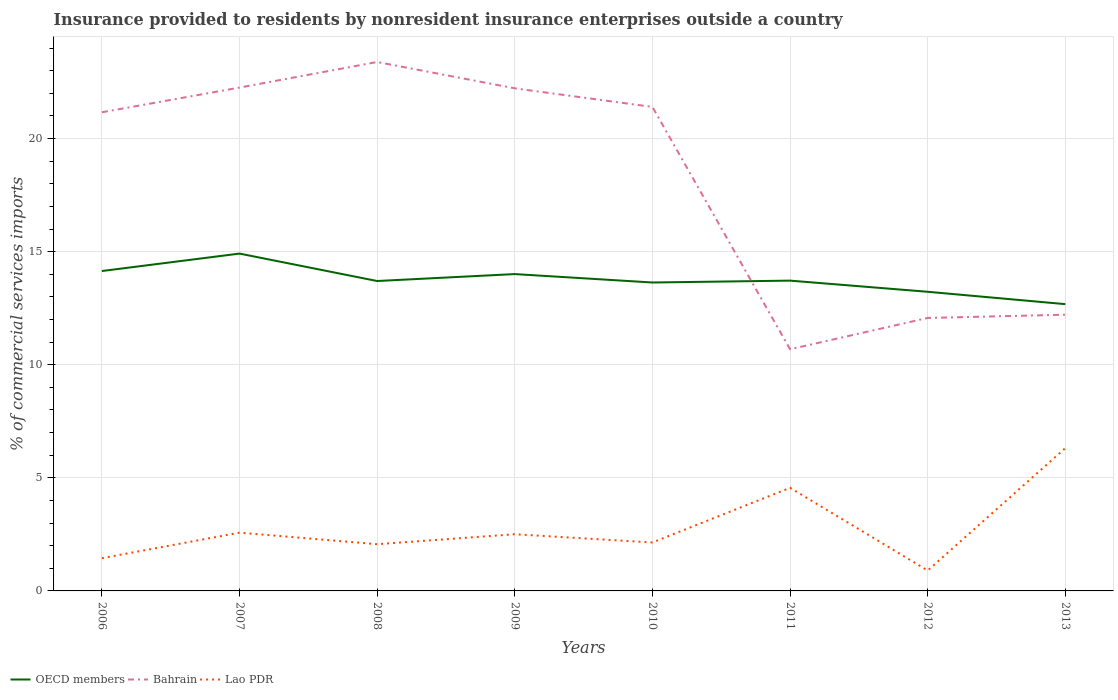How many different coloured lines are there?
Your answer should be very brief. 3. Does the line corresponding to Lao PDR intersect with the line corresponding to OECD members?
Offer a very short reply. No. Is the number of lines equal to the number of legend labels?
Your answer should be very brief. Yes. Across all years, what is the maximum Insurance provided to residents in Lao PDR?
Make the answer very short. 0.9. In which year was the Insurance provided to residents in Bahrain maximum?
Give a very brief answer. 2011. What is the total Insurance provided to residents in OECD members in the graph?
Your response must be concise. 0.44. What is the difference between the highest and the second highest Insurance provided to residents in OECD members?
Offer a terse response. 2.24. What is the difference between the highest and the lowest Insurance provided to residents in Bahrain?
Keep it short and to the point. 5. How many years are there in the graph?
Ensure brevity in your answer.  8. Are the values on the major ticks of Y-axis written in scientific E-notation?
Your answer should be compact. No. Where does the legend appear in the graph?
Ensure brevity in your answer.  Bottom left. How many legend labels are there?
Ensure brevity in your answer.  3. What is the title of the graph?
Give a very brief answer. Insurance provided to residents by nonresident insurance enterprises outside a country. What is the label or title of the X-axis?
Your response must be concise. Years. What is the label or title of the Y-axis?
Ensure brevity in your answer.  % of commercial services imports. What is the % of commercial services imports in OECD members in 2006?
Your answer should be compact. 14.14. What is the % of commercial services imports in Bahrain in 2006?
Provide a short and direct response. 21.16. What is the % of commercial services imports in Lao PDR in 2006?
Give a very brief answer. 1.45. What is the % of commercial services imports of OECD members in 2007?
Your answer should be compact. 14.91. What is the % of commercial services imports of Bahrain in 2007?
Provide a succinct answer. 22.25. What is the % of commercial services imports of Lao PDR in 2007?
Offer a very short reply. 2.58. What is the % of commercial services imports of OECD members in 2008?
Offer a terse response. 13.7. What is the % of commercial services imports in Bahrain in 2008?
Keep it short and to the point. 23.39. What is the % of commercial services imports of Lao PDR in 2008?
Make the answer very short. 2.07. What is the % of commercial services imports of OECD members in 2009?
Offer a very short reply. 14.01. What is the % of commercial services imports in Bahrain in 2009?
Your response must be concise. 22.22. What is the % of commercial services imports in Lao PDR in 2009?
Provide a short and direct response. 2.51. What is the % of commercial services imports of OECD members in 2010?
Give a very brief answer. 13.64. What is the % of commercial services imports in Bahrain in 2010?
Your response must be concise. 21.4. What is the % of commercial services imports of Lao PDR in 2010?
Keep it short and to the point. 2.14. What is the % of commercial services imports of OECD members in 2011?
Give a very brief answer. 13.72. What is the % of commercial services imports in Bahrain in 2011?
Give a very brief answer. 10.68. What is the % of commercial services imports in Lao PDR in 2011?
Provide a succinct answer. 4.56. What is the % of commercial services imports in OECD members in 2012?
Give a very brief answer. 13.23. What is the % of commercial services imports in Bahrain in 2012?
Make the answer very short. 12.07. What is the % of commercial services imports in Lao PDR in 2012?
Make the answer very short. 0.9. What is the % of commercial services imports of OECD members in 2013?
Your answer should be compact. 12.68. What is the % of commercial services imports of Bahrain in 2013?
Ensure brevity in your answer.  12.21. What is the % of commercial services imports of Lao PDR in 2013?
Keep it short and to the point. 6.31. Across all years, what is the maximum % of commercial services imports of OECD members?
Give a very brief answer. 14.91. Across all years, what is the maximum % of commercial services imports of Bahrain?
Give a very brief answer. 23.39. Across all years, what is the maximum % of commercial services imports of Lao PDR?
Your answer should be compact. 6.31. Across all years, what is the minimum % of commercial services imports of OECD members?
Ensure brevity in your answer.  12.68. Across all years, what is the minimum % of commercial services imports of Bahrain?
Keep it short and to the point. 10.68. Across all years, what is the minimum % of commercial services imports in Lao PDR?
Offer a very short reply. 0.9. What is the total % of commercial services imports in OECD members in the graph?
Ensure brevity in your answer.  110.03. What is the total % of commercial services imports of Bahrain in the graph?
Offer a very short reply. 145.39. What is the total % of commercial services imports in Lao PDR in the graph?
Give a very brief answer. 22.51. What is the difference between the % of commercial services imports of OECD members in 2006 and that in 2007?
Provide a short and direct response. -0.77. What is the difference between the % of commercial services imports in Bahrain in 2006 and that in 2007?
Make the answer very short. -1.09. What is the difference between the % of commercial services imports of Lao PDR in 2006 and that in 2007?
Your answer should be very brief. -1.13. What is the difference between the % of commercial services imports of OECD members in 2006 and that in 2008?
Provide a succinct answer. 0.44. What is the difference between the % of commercial services imports in Bahrain in 2006 and that in 2008?
Give a very brief answer. -2.22. What is the difference between the % of commercial services imports of Lao PDR in 2006 and that in 2008?
Make the answer very short. -0.62. What is the difference between the % of commercial services imports of OECD members in 2006 and that in 2009?
Make the answer very short. 0.14. What is the difference between the % of commercial services imports of Bahrain in 2006 and that in 2009?
Provide a short and direct response. -1.06. What is the difference between the % of commercial services imports in Lao PDR in 2006 and that in 2009?
Your answer should be compact. -1.06. What is the difference between the % of commercial services imports of OECD members in 2006 and that in 2010?
Your response must be concise. 0.51. What is the difference between the % of commercial services imports in Bahrain in 2006 and that in 2010?
Your response must be concise. -0.24. What is the difference between the % of commercial services imports of Lao PDR in 2006 and that in 2010?
Your answer should be very brief. -0.69. What is the difference between the % of commercial services imports of OECD members in 2006 and that in 2011?
Provide a short and direct response. 0.42. What is the difference between the % of commercial services imports of Bahrain in 2006 and that in 2011?
Provide a short and direct response. 10.48. What is the difference between the % of commercial services imports of Lao PDR in 2006 and that in 2011?
Give a very brief answer. -3.11. What is the difference between the % of commercial services imports in OECD members in 2006 and that in 2012?
Offer a very short reply. 0.92. What is the difference between the % of commercial services imports of Bahrain in 2006 and that in 2012?
Provide a short and direct response. 9.09. What is the difference between the % of commercial services imports in Lao PDR in 2006 and that in 2012?
Keep it short and to the point. 0.55. What is the difference between the % of commercial services imports in OECD members in 2006 and that in 2013?
Your answer should be very brief. 1.46. What is the difference between the % of commercial services imports in Bahrain in 2006 and that in 2013?
Keep it short and to the point. 8.95. What is the difference between the % of commercial services imports of Lao PDR in 2006 and that in 2013?
Provide a succinct answer. -4.87. What is the difference between the % of commercial services imports of OECD members in 2007 and that in 2008?
Provide a short and direct response. 1.21. What is the difference between the % of commercial services imports of Bahrain in 2007 and that in 2008?
Your answer should be compact. -1.13. What is the difference between the % of commercial services imports in Lao PDR in 2007 and that in 2008?
Give a very brief answer. 0.51. What is the difference between the % of commercial services imports in OECD members in 2007 and that in 2009?
Offer a terse response. 0.91. What is the difference between the % of commercial services imports of Bahrain in 2007 and that in 2009?
Make the answer very short. 0.03. What is the difference between the % of commercial services imports of Lao PDR in 2007 and that in 2009?
Your response must be concise. 0.07. What is the difference between the % of commercial services imports in OECD members in 2007 and that in 2010?
Keep it short and to the point. 1.28. What is the difference between the % of commercial services imports in Bahrain in 2007 and that in 2010?
Provide a succinct answer. 0.86. What is the difference between the % of commercial services imports of Lao PDR in 2007 and that in 2010?
Keep it short and to the point. 0.43. What is the difference between the % of commercial services imports in OECD members in 2007 and that in 2011?
Keep it short and to the point. 1.2. What is the difference between the % of commercial services imports in Bahrain in 2007 and that in 2011?
Your response must be concise. 11.57. What is the difference between the % of commercial services imports of Lao PDR in 2007 and that in 2011?
Give a very brief answer. -1.98. What is the difference between the % of commercial services imports of OECD members in 2007 and that in 2012?
Provide a succinct answer. 1.69. What is the difference between the % of commercial services imports in Bahrain in 2007 and that in 2012?
Your answer should be compact. 10.19. What is the difference between the % of commercial services imports in Lao PDR in 2007 and that in 2012?
Offer a terse response. 1.67. What is the difference between the % of commercial services imports of OECD members in 2007 and that in 2013?
Provide a short and direct response. 2.24. What is the difference between the % of commercial services imports of Bahrain in 2007 and that in 2013?
Make the answer very short. 10.04. What is the difference between the % of commercial services imports in Lao PDR in 2007 and that in 2013?
Your response must be concise. -3.74. What is the difference between the % of commercial services imports of OECD members in 2008 and that in 2009?
Make the answer very short. -0.31. What is the difference between the % of commercial services imports of Bahrain in 2008 and that in 2009?
Provide a short and direct response. 1.16. What is the difference between the % of commercial services imports of Lao PDR in 2008 and that in 2009?
Make the answer very short. -0.44. What is the difference between the % of commercial services imports of OECD members in 2008 and that in 2010?
Make the answer very short. 0.07. What is the difference between the % of commercial services imports in Bahrain in 2008 and that in 2010?
Make the answer very short. 1.99. What is the difference between the % of commercial services imports in Lao PDR in 2008 and that in 2010?
Your answer should be very brief. -0.08. What is the difference between the % of commercial services imports of OECD members in 2008 and that in 2011?
Offer a very short reply. -0.02. What is the difference between the % of commercial services imports of Bahrain in 2008 and that in 2011?
Keep it short and to the point. 12.7. What is the difference between the % of commercial services imports of Lao PDR in 2008 and that in 2011?
Offer a terse response. -2.49. What is the difference between the % of commercial services imports in OECD members in 2008 and that in 2012?
Provide a short and direct response. 0.48. What is the difference between the % of commercial services imports in Bahrain in 2008 and that in 2012?
Ensure brevity in your answer.  11.32. What is the difference between the % of commercial services imports in Lao PDR in 2008 and that in 2012?
Your answer should be very brief. 1.16. What is the difference between the % of commercial services imports in OECD members in 2008 and that in 2013?
Keep it short and to the point. 1.02. What is the difference between the % of commercial services imports in Bahrain in 2008 and that in 2013?
Your answer should be very brief. 11.17. What is the difference between the % of commercial services imports in Lao PDR in 2008 and that in 2013?
Keep it short and to the point. -4.25. What is the difference between the % of commercial services imports of OECD members in 2009 and that in 2010?
Offer a terse response. 0.37. What is the difference between the % of commercial services imports of Bahrain in 2009 and that in 2010?
Provide a succinct answer. 0.82. What is the difference between the % of commercial services imports in Lao PDR in 2009 and that in 2010?
Give a very brief answer. 0.36. What is the difference between the % of commercial services imports of OECD members in 2009 and that in 2011?
Offer a terse response. 0.29. What is the difference between the % of commercial services imports of Bahrain in 2009 and that in 2011?
Your answer should be very brief. 11.54. What is the difference between the % of commercial services imports of Lao PDR in 2009 and that in 2011?
Your answer should be compact. -2.05. What is the difference between the % of commercial services imports in OECD members in 2009 and that in 2012?
Provide a succinct answer. 0.78. What is the difference between the % of commercial services imports in Bahrain in 2009 and that in 2012?
Your answer should be very brief. 10.15. What is the difference between the % of commercial services imports in Lao PDR in 2009 and that in 2012?
Give a very brief answer. 1.6. What is the difference between the % of commercial services imports in OECD members in 2009 and that in 2013?
Ensure brevity in your answer.  1.33. What is the difference between the % of commercial services imports in Bahrain in 2009 and that in 2013?
Your answer should be compact. 10.01. What is the difference between the % of commercial services imports of Lao PDR in 2009 and that in 2013?
Give a very brief answer. -3.81. What is the difference between the % of commercial services imports in OECD members in 2010 and that in 2011?
Your answer should be very brief. -0.08. What is the difference between the % of commercial services imports in Bahrain in 2010 and that in 2011?
Offer a terse response. 10.71. What is the difference between the % of commercial services imports in Lao PDR in 2010 and that in 2011?
Your response must be concise. -2.42. What is the difference between the % of commercial services imports in OECD members in 2010 and that in 2012?
Provide a succinct answer. 0.41. What is the difference between the % of commercial services imports in Bahrain in 2010 and that in 2012?
Offer a very short reply. 9.33. What is the difference between the % of commercial services imports in Lao PDR in 2010 and that in 2012?
Keep it short and to the point. 1.24. What is the difference between the % of commercial services imports in OECD members in 2010 and that in 2013?
Your response must be concise. 0.96. What is the difference between the % of commercial services imports in Bahrain in 2010 and that in 2013?
Make the answer very short. 9.19. What is the difference between the % of commercial services imports in Lao PDR in 2010 and that in 2013?
Keep it short and to the point. -4.17. What is the difference between the % of commercial services imports in OECD members in 2011 and that in 2012?
Offer a terse response. 0.49. What is the difference between the % of commercial services imports in Bahrain in 2011 and that in 2012?
Give a very brief answer. -1.38. What is the difference between the % of commercial services imports of Lao PDR in 2011 and that in 2012?
Make the answer very short. 3.66. What is the difference between the % of commercial services imports in OECD members in 2011 and that in 2013?
Offer a very short reply. 1.04. What is the difference between the % of commercial services imports of Bahrain in 2011 and that in 2013?
Provide a short and direct response. -1.53. What is the difference between the % of commercial services imports in Lao PDR in 2011 and that in 2013?
Give a very brief answer. -1.76. What is the difference between the % of commercial services imports of OECD members in 2012 and that in 2013?
Provide a short and direct response. 0.55. What is the difference between the % of commercial services imports of Bahrain in 2012 and that in 2013?
Offer a very short reply. -0.14. What is the difference between the % of commercial services imports of Lao PDR in 2012 and that in 2013?
Provide a short and direct response. -5.41. What is the difference between the % of commercial services imports of OECD members in 2006 and the % of commercial services imports of Bahrain in 2007?
Make the answer very short. -8.11. What is the difference between the % of commercial services imports in OECD members in 2006 and the % of commercial services imports in Lao PDR in 2007?
Your response must be concise. 11.57. What is the difference between the % of commercial services imports of Bahrain in 2006 and the % of commercial services imports of Lao PDR in 2007?
Your answer should be very brief. 18.59. What is the difference between the % of commercial services imports of OECD members in 2006 and the % of commercial services imports of Bahrain in 2008?
Your response must be concise. -9.24. What is the difference between the % of commercial services imports of OECD members in 2006 and the % of commercial services imports of Lao PDR in 2008?
Your answer should be compact. 12.08. What is the difference between the % of commercial services imports of Bahrain in 2006 and the % of commercial services imports of Lao PDR in 2008?
Your answer should be compact. 19.1. What is the difference between the % of commercial services imports of OECD members in 2006 and the % of commercial services imports of Bahrain in 2009?
Your answer should be compact. -8.08. What is the difference between the % of commercial services imports of OECD members in 2006 and the % of commercial services imports of Lao PDR in 2009?
Offer a terse response. 11.64. What is the difference between the % of commercial services imports of Bahrain in 2006 and the % of commercial services imports of Lao PDR in 2009?
Your answer should be compact. 18.66. What is the difference between the % of commercial services imports in OECD members in 2006 and the % of commercial services imports in Bahrain in 2010?
Your answer should be compact. -7.25. What is the difference between the % of commercial services imports of OECD members in 2006 and the % of commercial services imports of Lao PDR in 2010?
Offer a terse response. 12. What is the difference between the % of commercial services imports of Bahrain in 2006 and the % of commercial services imports of Lao PDR in 2010?
Keep it short and to the point. 19.02. What is the difference between the % of commercial services imports in OECD members in 2006 and the % of commercial services imports in Bahrain in 2011?
Provide a succinct answer. 3.46. What is the difference between the % of commercial services imports in OECD members in 2006 and the % of commercial services imports in Lao PDR in 2011?
Your answer should be very brief. 9.59. What is the difference between the % of commercial services imports of Bahrain in 2006 and the % of commercial services imports of Lao PDR in 2011?
Give a very brief answer. 16.6. What is the difference between the % of commercial services imports of OECD members in 2006 and the % of commercial services imports of Bahrain in 2012?
Your response must be concise. 2.07. What is the difference between the % of commercial services imports in OECD members in 2006 and the % of commercial services imports in Lao PDR in 2012?
Offer a very short reply. 13.24. What is the difference between the % of commercial services imports of Bahrain in 2006 and the % of commercial services imports of Lao PDR in 2012?
Provide a succinct answer. 20.26. What is the difference between the % of commercial services imports of OECD members in 2006 and the % of commercial services imports of Bahrain in 2013?
Your answer should be very brief. 1.93. What is the difference between the % of commercial services imports of OECD members in 2006 and the % of commercial services imports of Lao PDR in 2013?
Your answer should be compact. 7.83. What is the difference between the % of commercial services imports in Bahrain in 2006 and the % of commercial services imports in Lao PDR in 2013?
Keep it short and to the point. 14.85. What is the difference between the % of commercial services imports of OECD members in 2007 and the % of commercial services imports of Bahrain in 2008?
Your response must be concise. -8.47. What is the difference between the % of commercial services imports of OECD members in 2007 and the % of commercial services imports of Lao PDR in 2008?
Provide a succinct answer. 12.85. What is the difference between the % of commercial services imports of Bahrain in 2007 and the % of commercial services imports of Lao PDR in 2008?
Provide a succinct answer. 20.19. What is the difference between the % of commercial services imports in OECD members in 2007 and the % of commercial services imports in Bahrain in 2009?
Ensure brevity in your answer.  -7.31. What is the difference between the % of commercial services imports of OECD members in 2007 and the % of commercial services imports of Lao PDR in 2009?
Your answer should be very brief. 12.41. What is the difference between the % of commercial services imports of Bahrain in 2007 and the % of commercial services imports of Lao PDR in 2009?
Offer a terse response. 19.75. What is the difference between the % of commercial services imports in OECD members in 2007 and the % of commercial services imports in Bahrain in 2010?
Ensure brevity in your answer.  -6.48. What is the difference between the % of commercial services imports of OECD members in 2007 and the % of commercial services imports of Lao PDR in 2010?
Your answer should be compact. 12.77. What is the difference between the % of commercial services imports of Bahrain in 2007 and the % of commercial services imports of Lao PDR in 2010?
Give a very brief answer. 20.11. What is the difference between the % of commercial services imports in OECD members in 2007 and the % of commercial services imports in Bahrain in 2011?
Offer a very short reply. 4.23. What is the difference between the % of commercial services imports in OECD members in 2007 and the % of commercial services imports in Lao PDR in 2011?
Your answer should be compact. 10.36. What is the difference between the % of commercial services imports in Bahrain in 2007 and the % of commercial services imports in Lao PDR in 2011?
Your answer should be very brief. 17.7. What is the difference between the % of commercial services imports of OECD members in 2007 and the % of commercial services imports of Bahrain in 2012?
Ensure brevity in your answer.  2.85. What is the difference between the % of commercial services imports of OECD members in 2007 and the % of commercial services imports of Lao PDR in 2012?
Provide a succinct answer. 14.01. What is the difference between the % of commercial services imports in Bahrain in 2007 and the % of commercial services imports in Lao PDR in 2012?
Your answer should be compact. 21.35. What is the difference between the % of commercial services imports in OECD members in 2007 and the % of commercial services imports in Bahrain in 2013?
Provide a succinct answer. 2.7. What is the difference between the % of commercial services imports in Bahrain in 2007 and the % of commercial services imports in Lao PDR in 2013?
Offer a very short reply. 15.94. What is the difference between the % of commercial services imports of OECD members in 2008 and the % of commercial services imports of Bahrain in 2009?
Provide a succinct answer. -8.52. What is the difference between the % of commercial services imports of OECD members in 2008 and the % of commercial services imports of Lao PDR in 2009?
Keep it short and to the point. 11.2. What is the difference between the % of commercial services imports of Bahrain in 2008 and the % of commercial services imports of Lao PDR in 2009?
Give a very brief answer. 20.88. What is the difference between the % of commercial services imports in OECD members in 2008 and the % of commercial services imports in Bahrain in 2010?
Give a very brief answer. -7.7. What is the difference between the % of commercial services imports of OECD members in 2008 and the % of commercial services imports of Lao PDR in 2010?
Provide a short and direct response. 11.56. What is the difference between the % of commercial services imports of Bahrain in 2008 and the % of commercial services imports of Lao PDR in 2010?
Give a very brief answer. 21.24. What is the difference between the % of commercial services imports in OECD members in 2008 and the % of commercial services imports in Bahrain in 2011?
Your response must be concise. 3.02. What is the difference between the % of commercial services imports of OECD members in 2008 and the % of commercial services imports of Lao PDR in 2011?
Make the answer very short. 9.14. What is the difference between the % of commercial services imports of Bahrain in 2008 and the % of commercial services imports of Lao PDR in 2011?
Offer a terse response. 18.83. What is the difference between the % of commercial services imports of OECD members in 2008 and the % of commercial services imports of Bahrain in 2012?
Your response must be concise. 1.63. What is the difference between the % of commercial services imports in OECD members in 2008 and the % of commercial services imports in Lao PDR in 2012?
Make the answer very short. 12.8. What is the difference between the % of commercial services imports of Bahrain in 2008 and the % of commercial services imports of Lao PDR in 2012?
Keep it short and to the point. 22.48. What is the difference between the % of commercial services imports in OECD members in 2008 and the % of commercial services imports in Bahrain in 2013?
Offer a very short reply. 1.49. What is the difference between the % of commercial services imports of OECD members in 2008 and the % of commercial services imports of Lao PDR in 2013?
Provide a short and direct response. 7.39. What is the difference between the % of commercial services imports in Bahrain in 2008 and the % of commercial services imports in Lao PDR in 2013?
Your answer should be compact. 17.07. What is the difference between the % of commercial services imports in OECD members in 2009 and the % of commercial services imports in Bahrain in 2010?
Ensure brevity in your answer.  -7.39. What is the difference between the % of commercial services imports of OECD members in 2009 and the % of commercial services imports of Lao PDR in 2010?
Your response must be concise. 11.87. What is the difference between the % of commercial services imports in Bahrain in 2009 and the % of commercial services imports in Lao PDR in 2010?
Offer a terse response. 20.08. What is the difference between the % of commercial services imports in OECD members in 2009 and the % of commercial services imports in Bahrain in 2011?
Your answer should be compact. 3.32. What is the difference between the % of commercial services imports in OECD members in 2009 and the % of commercial services imports in Lao PDR in 2011?
Your response must be concise. 9.45. What is the difference between the % of commercial services imports of Bahrain in 2009 and the % of commercial services imports of Lao PDR in 2011?
Your answer should be very brief. 17.66. What is the difference between the % of commercial services imports of OECD members in 2009 and the % of commercial services imports of Bahrain in 2012?
Your response must be concise. 1.94. What is the difference between the % of commercial services imports in OECD members in 2009 and the % of commercial services imports in Lao PDR in 2012?
Provide a succinct answer. 13.11. What is the difference between the % of commercial services imports in Bahrain in 2009 and the % of commercial services imports in Lao PDR in 2012?
Your response must be concise. 21.32. What is the difference between the % of commercial services imports in OECD members in 2009 and the % of commercial services imports in Bahrain in 2013?
Your response must be concise. 1.8. What is the difference between the % of commercial services imports in OECD members in 2009 and the % of commercial services imports in Lao PDR in 2013?
Provide a short and direct response. 7.69. What is the difference between the % of commercial services imports in Bahrain in 2009 and the % of commercial services imports in Lao PDR in 2013?
Your response must be concise. 15.91. What is the difference between the % of commercial services imports of OECD members in 2010 and the % of commercial services imports of Bahrain in 2011?
Offer a very short reply. 2.95. What is the difference between the % of commercial services imports in OECD members in 2010 and the % of commercial services imports in Lao PDR in 2011?
Keep it short and to the point. 9.08. What is the difference between the % of commercial services imports in Bahrain in 2010 and the % of commercial services imports in Lao PDR in 2011?
Give a very brief answer. 16.84. What is the difference between the % of commercial services imports of OECD members in 2010 and the % of commercial services imports of Bahrain in 2012?
Offer a terse response. 1.57. What is the difference between the % of commercial services imports of OECD members in 2010 and the % of commercial services imports of Lao PDR in 2012?
Keep it short and to the point. 12.73. What is the difference between the % of commercial services imports of Bahrain in 2010 and the % of commercial services imports of Lao PDR in 2012?
Make the answer very short. 20.5. What is the difference between the % of commercial services imports in OECD members in 2010 and the % of commercial services imports in Bahrain in 2013?
Your answer should be compact. 1.42. What is the difference between the % of commercial services imports in OECD members in 2010 and the % of commercial services imports in Lao PDR in 2013?
Provide a short and direct response. 7.32. What is the difference between the % of commercial services imports in Bahrain in 2010 and the % of commercial services imports in Lao PDR in 2013?
Keep it short and to the point. 15.08. What is the difference between the % of commercial services imports in OECD members in 2011 and the % of commercial services imports in Bahrain in 2012?
Make the answer very short. 1.65. What is the difference between the % of commercial services imports in OECD members in 2011 and the % of commercial services imports in Lao PDR in 2012?
Your answer should be compact. 12.82. What is the difference between the % of commercial services imports in Bahrain in 2011 and the % of commercial services imports in Lao PDR in 2012?
Keep it short and to the point. 9.78. What is the difference between the % of commercial services imports of OECD members in 2011 and the % of commercial services imports of Bahrain in 2013?
Make the answer very short. 1.51. What is the difference between the % of commercial services imports of OECD members in 2011 and the % of commercial services imports of Lao PDR in 2013?
Give a very brief answer. 7.4. What is the difference between the % of commercial services imports in Bahrain in 2011 and the % of commercial services imports in Lao PDR in 2013?
Provide a short and direct response. 4.37. What is the difference between the % of commercial services imports in OECD members in 2012 and the % of commercial services imports in Bahrain in 2013?
Make the answer very short. 1.01. What is the difference between the % of commercial services imports of OECD members in 2012 and the % of commercial services imports of Lao PDR in 2013?
Make the answer very short. 6.91. What is the difference between the % of commercial services imports in Bahrain in 2012 and the % of commercial services imports in Lao PDR in 2013?
Offer a terse response. 5.75. What is the average % of commercial services imports of OECD members per year?
Your response must be concise. 13.75. What is the average % of commercial services imports in Bahrain per year?
Make the answer very short. 18.17. What is the average % of commercial services imports of Lao PDR per year?
Your response must be concise. 2.81. In the year 2006, what is the difference between the % of commercial services imports of OECD members and % of commercial services imports of Bahrain?
Keep it short and to the point. -7.02. In the year 2006, what is the difference between the % of commercial services imports of OECD members and % of commercial services imports of Lao PDR?
Your answer should be compact. 12.7. In the year 2006, what is the difference between the % of commercial services imports of Bahrain and % of commercial services imports of Lao PDR?
Your response must be concise. 19.71. In the year 2007, what is the difference between the % of commercial services imports in OECD members and % of commercial services imports in Bahrain?
Give a very brief answer. -7.34. In the year 2007, what is the difference between the % of commercial services imports in OECD members and % of commercial services imports in Lao PDR?
Your answer should be compact. 12.34. In the year 2007, what is the difference between the % of commercial services imports in Bahrain and % of commercial services imports in Lao PDR?
Your answer should be very brief. 19.68. In the year 2008, what is the difference between the % of commercial services imports in OECD members and % of commercial services imports in Bahrain?
Offer a terse response. -9.68. In the year 2008, what is the difference between the % of commercial services imports of OECD members and % of commercial services imports of Lao PDR?
Offer a very short reply. 11.64. In the year 2008, what is the difference between the % of commercial services imports in Bahrain and % of commercial services imports in Lao PDR?
Give a very brief answer. 21.32. In the year 2009, what is the difference between the % of commercial services imports in OECD members and % of commercial services imports in Bahrain?
Provide a succinct answer. -8.21. In the year 2009, what is the difference between the % of commercial services imports in OECD members and % of commercial services imports in Lao PDR?
Ensure brevity in your answer.  11.5. In the year 2009, what is the difference between the % of commercial services imports in Bahrain and % of commercial services imports in Lao PDR?
Provide a short and direct response. 19.72. In the year 2010, what is the difference between the % of commercial services imports of OECD members and % of commercial services imports of Bahrain?
Provide a short and direct response. -7.76. In the year 2010, what is the difference between the % of commercial services imports of OECD members and % of commercial services imports of Lao PDR?
Keep it short and to the point. 11.49. In the year 2010, what is the difference between the % of commercial services imports of Bahrain and % of commercial services imports of Lao PDR?
Ensure brevity in your answer.  19.26. In the year 2011, what is the difference between the % of commercial services imports of OECD members and % of commercial services imports of Bahrain?
Provide a short and direct response. 3.03. In the year 2011, what is the difference between the % of commercial services imports of OECD members and % of commercial services imports of Lao PDR?
Make the answer very short. 9.16. In the year 2011, what is the difference between the % of commercial services imports in Bahrain and % of commercial services imports in Lao PDR?
Offer a very short reply. 6.13. In the year 2012, what is the difference between the % of commercial services imports in OECD members and % of commercial services imports in Bahrain?
Provide a short and direct response. 1.16. In the year 2012, what is the difference between the % of commercial services imports of OECD members and % of commercial services imports of Lao PDR?
Keep it short and to the point. 12.32. In the year 2012, what is the difference between the % of commercial services imports of Bahrain and % of commercial services imports of Lao PDR?
Your answer should be compact. 11.17. In the year 2013, what is the difference between the % of commercial services imports of OECD members and % of commercial services imports of Bahrain?
Your response must be concise. 0.47. In the year 2013, what is the difference between the % of commercial services imports in OECD members and % of commercial services imports in Lao PDR?
Offer a very short reply. 6.36. In the year 2013, what is the difference between the % of commercial services imports in Bahrain and % of commercial services imports in Lao PDR?
Make the answer very short. 5.9. What is the ratio of the % of commercial services imports in OECD members in 2006 to that in 2007?
Ensure brevity in your answer.  0.95. What is the ratio of the % of commercial services imports in Bahrain in 2006 to that in 2007?
Give a very brief answer. 0.95. What is the ratio of the % of commercial services imports in Lao PDR in 2006 to that in 2007?
Offer a terse response. 0.56. What is the ratio of the % of commercial services imports of OECD members in 2006 to that in 2008?
Offer a very short reply. 1.03. What is the ratio of the % of commercial services imports of Bahrain in 2006 to that in 2008?
Offer a terse response. 0.91. What is the ratio of the % of commercial services imports of Lao PDR in 2006 to that in 2008?
Give a very brief answer. 0.7. What is the ratio of the % of commercial services imports in OECD members in 2006 to that in 2009?
Make the answer very short. 1.01. What is the ratio of the % of commercial services imports in Bahrain in 2006 to that in 2009?
Your answer should be very brief. 0.95. What is the ratio of the % of commercial services imports of Lao PDR in 2006 to that in 2009?
Provide a succinct answer. 0.58. What is the ratio of the % of commercial services imports of OECD members in 2006 to that in 2010?
Your answer should be very brief. 1.04. What is the ratio of the % of commercial services imports in Bahrain in 2006 to that in 2010?
Your answer should be very brief. 0.99. What is the ratio of the % of commercial services imports of Lao PDR in 2006 to that in 2010?
Provide a short and direct response. 0.68. What is the ratio of the % of commercial services imports of OECD members in 2006 to that in 2011?
Offer a terse response. 1.03. What is the ratio of the % of commercial services imports of Bahrain in 2006 to that in 2011?
Ensure brevity in your answer.  1.98. What is the ratio of the % of commercial services imports in Lao PDR in 2006 to that in 2011?
Offer a very short reply. 0.32. What is the ratio of the % of commercial services imports in OECD members in 2006 to that in 2012?
Provide a succinct answer. 1.07. What is the ratio of the % of commercial services imports in Bahrain in 2006 to that in 2012?
Keep it short and to the point. 1.75. What is the ratio of the % of commercial services imports of Lao PDR in 2006 to that in 2012?
Your response must be concise. 1.61. What is the ratio of the % of commercial services imports in OECD members in 2006 to that in 2013?
Keep it short and to the point. 1.12. What is the ratio of the % of commercial services imports in Bahrain in 2006 to that in 2013?
Offer a terse response. 1.73. What is the ratio of the % of commercial services imports in Lao PDR in 2006 to that in 2013?
Provide a succinct answer. 0.23. What is the ratio of the % of commercial services imports in OECD members in 2007 to that in 2008?
Make the answer very short. 1.09. What is the ratio of the % of commercial services imports in Bahrain in 2007 to that in 2008?
Make the answer very short. 0.95. What is the ratio of the % of commercial services imports in Lao PDR in 2007 to that in 2008?
Ensure brevity in your answer.  1.25. What is the ratio of the % of commercial services imports in OECD members in 2007 to that in 2009?
Offer a very short reply. 1.06. What is the ratio of the % of commercial services imports of Lao PDR in 2007 to that in 2009?
Keep it short and to the point. 1.03. What is the ratio of the % of commercial services imports in OECD members in 2007 to that in 2010?
Give a very brief answer. 1.09. What is the ratio of the % of commercial services imports of Lao PDR in 2007 to that in 2010?
Ensure brevity in your answer.  1.2. What is the ratio of the % of commercial services imports in OECD members in 2007 to that in 2011?
Provide a succinct answer. 1.09. What is the ratio of the % of commercial services imports of Bahrain in 2007 to that in 2011?
Ensure brevity in your answer.  2.08. What is the ratio of the % of commercial services imports in Lao PDR in 2007 to that in 2011?
Your answer should be compact. 0.57. What is the ratio of the % of commercial services imports of OECD members in 2007 to that in 2012?
Provide a succinct answer. 1.13. What is the ratio of the % of commercial services imports in Bahrain in 2007 to that in 2012?
Give a very brief answer. 1.84. What is the ratio of the % of commercial services imports of Lao PDR in 2007 to that in 2012?
Your response must be concise. 2.86. What is the ratio of the % of commercial services imports in OECD members in 2007 to that in 2013?
Make the answer very short. 1.18. What is the ratio of the % of commercial services imports in Bahrain in 2007 to that in 2013?
Give a very brief answer. 1.82. What is the ratio of the % of commercial services imports in Lao PDR in 2007 to that in 2013?
Provide a succinct answer. 0.41. What is the ratio of the % of commercial services imports in OECD members in 2008 to that in 2009?
Offer a terse response. 0.98. What is the ratio of the % of commercial services imports in Bahrain in 2008 to that in 2009?
Offer a very short reply. 1.05. What is the ratio of the % of commercial services imports of Lao PDR in 2008 to that in 2009?
Keep it short and to the point. 0.82. What is the ratio of the % of commercial services imports of Bahrain in 2008 to that in 2010?
Provide a short and direct response. 1.09. What is the ratio of the % of commercial services imports of Lao PDR in 2008 to that in 2010?
Your answer should be compact. 0.96. What is the ratio of the % of commercial services imports in OECD members in 2008 to that in 2011?
Your answer should be compact. 1. What is the ratio of the % of commercial services imports of Bahrain in 2008 to that in 2011?
Offer a very short reply. 2.19. What is the ratio of the % of commercial services imports in Lao PDR in 2008 to that in 2011?
Ensure brevity in your answer.  0.45. What is the ratio of the % of commercial services imports of OECD members in 2008 to that in 2012?
Provide a succinct answer. 1.04. What is the ratio of the % of commercial services imports in Bahrain in 2008 to that in 2012?
Your answer should be very brief. 1.94. What is the ratio of the % of commercial services imports of Lao PDR in 2008 to that in 2012?
Give a very brief answer. 2.29. What is the ratio of the % of commercial services imports of OECD members in 2008 to that in 2013?
Ensure brevity in your answer.  1.08. What is the ratio of the % of commercial services imports in Bahrain in 2008 to that in 2013?
Ensure brevity in your answer.  1.91. What is the ratio of the % of commercial services imports in Lao PDR in 2008 to that in 2013?
Your answer should be very brief. 0.33. What is the ratio of the % of commercial services imports of OECD members in 2009 to that in 2010?
Your response must be concise. 1.03. What is the ratio of the % of commercial services imports of Bahrain in 2009 to that in 2010?
Keep it short and to the point. 1.04. What is the ratio of the % of commercial services imports in Lao PDR in 2009 to that in 2010?
Give a very brief answer. 1.17. What is the ratio of the % of commercial services imports in OECD members in 2009 to that in 2011?
Provide a short and direct response. 1.02. What is the ratio of the % of commercial services imports in Bahrain in 2009 to that in 2011?
Give a very brief answer. 2.08. What is the ratio of the % of commercial services imports in Lao PDR in 2009 to that in 2011?
Provide a short and direct response. 0.55. What is the ratio of the % of commercial services imports in OECD members in 2009 to that in 2012?
Make the answer very short. 1.06. What is the ratio of the % of commercial services imports in Bahrain in 2009 to that in 2012?
Provide a succinct answer. 1.84. What is the ratio of the % of commercial services imports in Lao PDR in 2009 to that in 2012?
Provide a short and direct response. 2.78. What is the ratio of the % of commercial services imports of OECD members in 2009 to that in 2013?
Offer a very short reply. 1.1. What is the ratio of the % of commercial services imports of Bahrain in 2009 to that in 2013?
Your response must be concise. 1.82. What is the ratio of the % of commercial services imports of Lao PDR in 2009 to that in 2013?
Provide a short and direct response. 0.4. What is the ratio of the % of commercial services imports in OECD members in 2010 to that in 2011?
Keep it short and to the point. 0.99. What is the ratio of the % of commercial services imports of Bahrain in 2010 to that in 2011?
Offer a terse response. 2. What is the ratio of the % of commercial services imports in Lao PDR in 2010 to that in 2011?
Your answer should be very brief. 0.47. What is the ratio of the % of commercial services imports in OECD members in 2010 to that in 2012?
Make the answer very short. 1.03. What is the ratio of the % of commercial services imports in Bahrain in 2010 to that in 2012?
Your response must be concise. 1.77. What is the ratio of the % of commercial services imports in Lao PDR in 2010 to that in 2012?
Make the answer very short. 2.38. What is the ratio of the % of commercial services imports in OECD members in 2010 to that in 2013?
Make the answer very short. 1.08. What is the ratio of the % of commercial services imports in Bahrain in 2010 to that in 2013?
Offer a very short reply. 1.75. What is the ratio of the % of commercial services imports in Lao PDR in 2010 to that in 2013?
Your answer should be compact. 0.34. What is the ratio of the % of commercial services imports of OECD members in 2011 to that in 2012?
Offer a terse response. 1.04. What is the ratio of the % of commercial services imports of Bahrain in 2011 to that in 2012?
Keep it short and to the point. 0.89. What is the ratio of the % of commercial services imports of Lao PDR in 2011 to that in 2012?
Your response must be concise. 5.06. What is the ratio of the % of commercial services imports of OECD members in 2011 to that in 2013?
Make the answer very short. 1.08. What is the ratio of the % of commercial services imports of Bahrain in 2011 to that in 2013?
Your answer should be compact. 0.87. What is the ratio of the % of commercial services imports of Lao PDR in 2011 to that in 2013?
Your answer should be compact. 0.72. What is the ratio of the % of commercial services imports of OECD members in 2012 to that in 2013?
Make the answer very short. 1.04. What is the ratio of the % of commercial services imports of Bahrain in 2012 to that in 2013?
Provide a succinct answer. 0.99. What is the ratio of the % of commercial services imports of Lao PDR in 2012 to that in 2013?
Offer a terse response. 0.14. What is the difference between the highest and the second highest % of commercial services imports of OECD members?
Give a very brief answer. 0.77. What is the difference between the highest and the second highest % of commercial services imports of Bahrain?
Your response must be concise. 1.13. What is the difference between the highest and the second highest % of commercial services imports of Lao PDR?
Offer a terse response. 1.76. What is the difference between the highest and the lowest % of commercial services imports of OECD members?
Give a very brief answer. 2.24. What is the difference between the highest and the lowest % of commercial services imports in Bahrain?
Offer a very short reply. 12.7. What is the difference between the highest and the lowest % of commercial services imports in Lao PDR?
Keep it short and to the point. 5.41. 